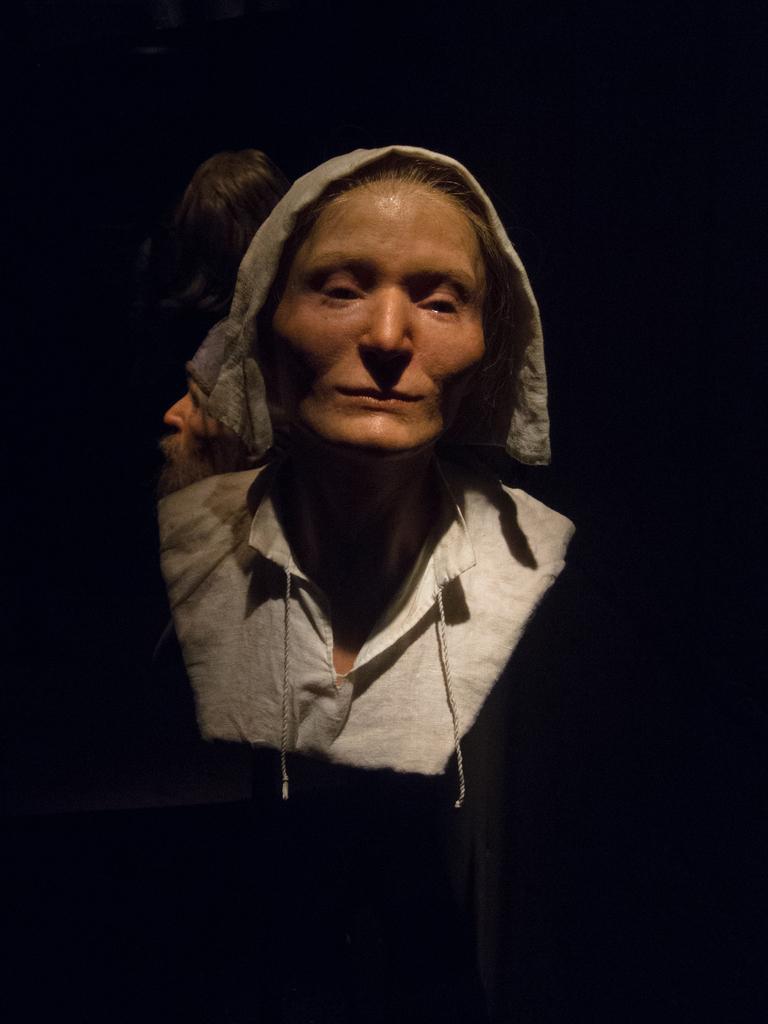How would you summarize this image in a sentence or two? This picture is dark, we can see a person and hair. 